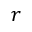<formula> <loc_0><loc_0><loc_500><loc_500>r</formula> 